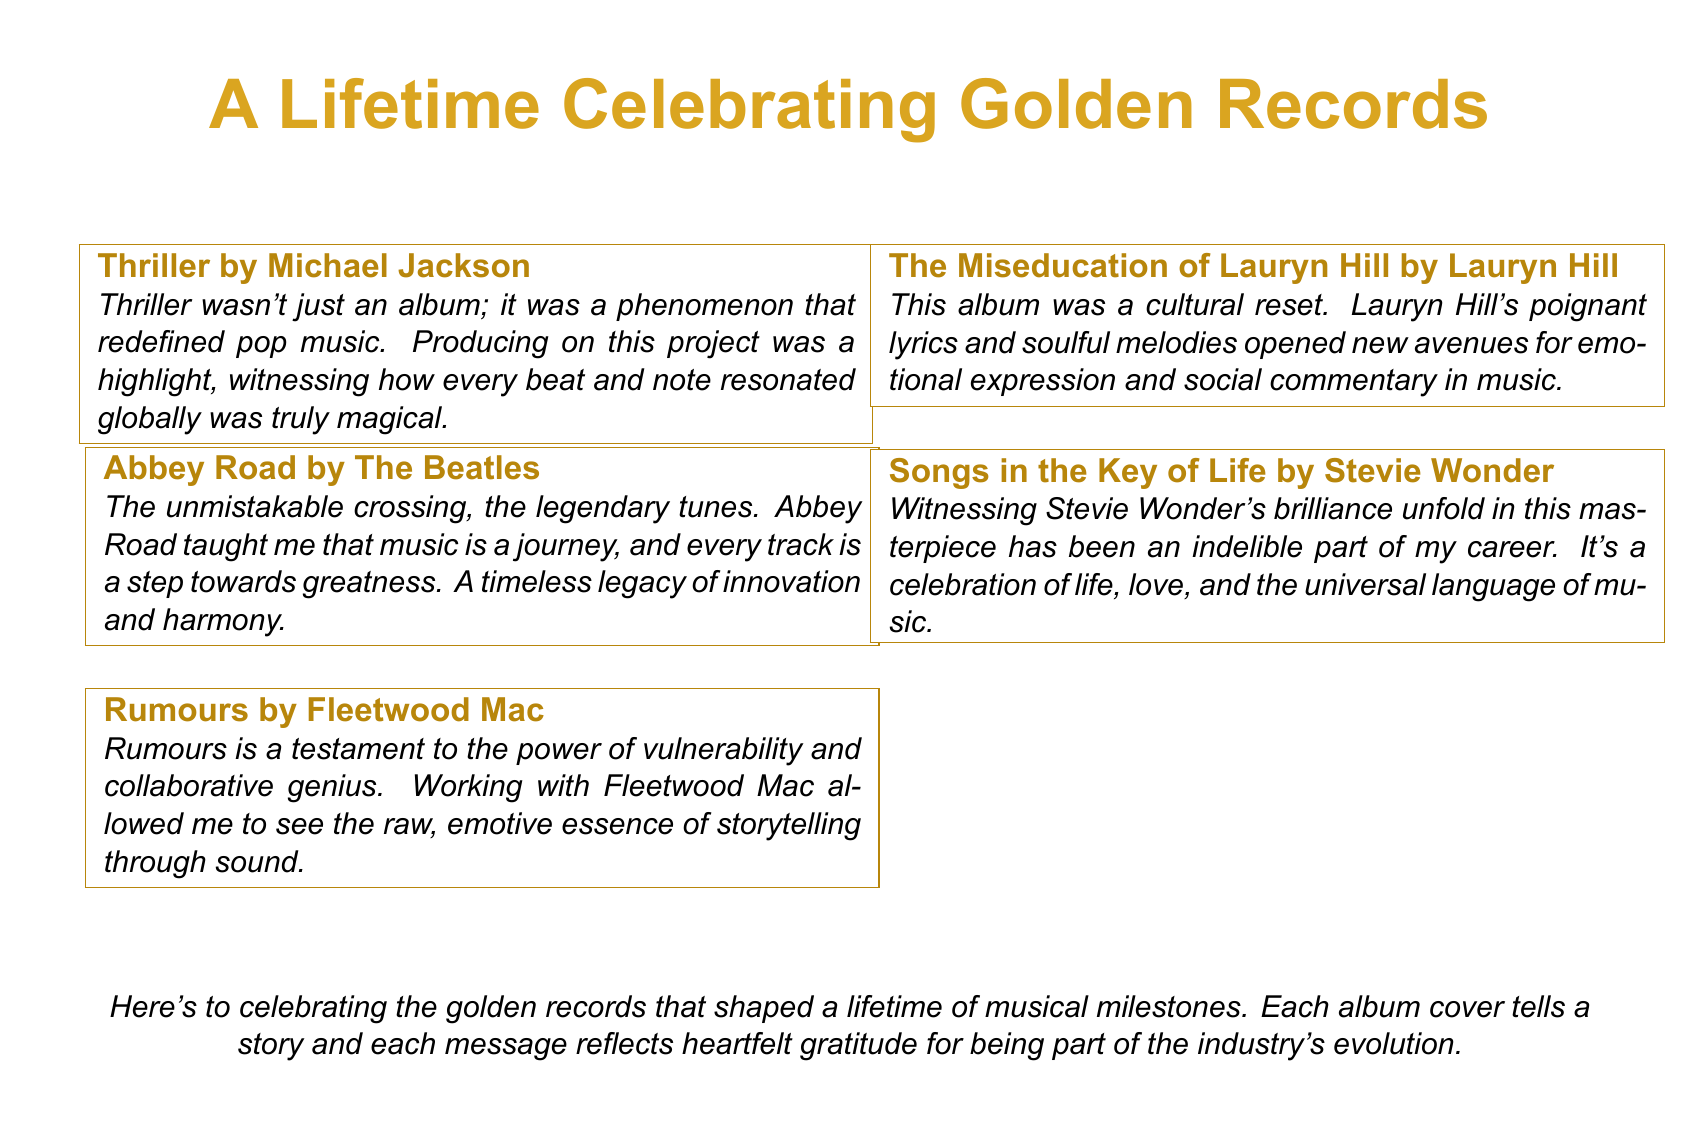What is the title of the document? The title is specified at the top of the document, which is "A Lifetime Celebrating Golden Records."
Answer: A Lifetime Celebrating Golden Records How many albums are featured in the document? There are five albums listed in the document.
Answer: 5 Who is the artist of the album "Rumours"? The album "Rumours" is by Fleetwood Mac, as stated in the message section.
Answer: Fleetwood Mac What color is used for the title? The title is colored in goldenrod, which can be identified in the title's format.
Answer: goldenrod What theme is expressed in the heartfelt messages? The messages reflect themes of appreciation and the impact of the albums on the music industry.
Answer: appreciation Which album is described as a "cultural reset"? The Miseducation of Lauryn Hill is referred to as a cultural reset in the corresponding message.
Answer: The Miseducation of Lauryn Hill What does the final message in the document summarize? The final message summarizes the celebration of musical milestones associated with the golden records.
Answer: celebration of musical milestones What does "Abbey Road" teach about music? The message implies that "Abbey Road" teaches the idea that music is a journey.
Answer: music is a journey Which artist's brilliance is highlighted in the album "Songs in the Key of Life"? Stevie Wonder's brilliance is highlighted in the message related to the album "Songs in the Key of Life."
Answer: Stevie Wonder 